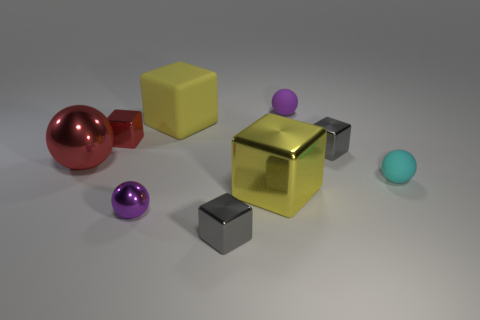Subtract all purple rubber spheres. How many spheres are left? 3 Subtract all red balls. How many balls are left? 3 Subtract all purple spheres. How many green blocks are left? 0 Add 1 tiny brown objects. How many objects exist? 10 Subtract 1 yellow blocks. How many objects are left? 8 Subtract all cubes. How many objects are left? 4 Subtract 5 blocks. How many blocks are left? 0 Subtract all purple blocks. Subtract all purple balls. How many blocks are left? 5 Subtract all red metallic blocks. Subtract all red metallic cubes. How many objects are left? 7 Add 9 yellow rubber things. How many yellow rubber things are left? 10 